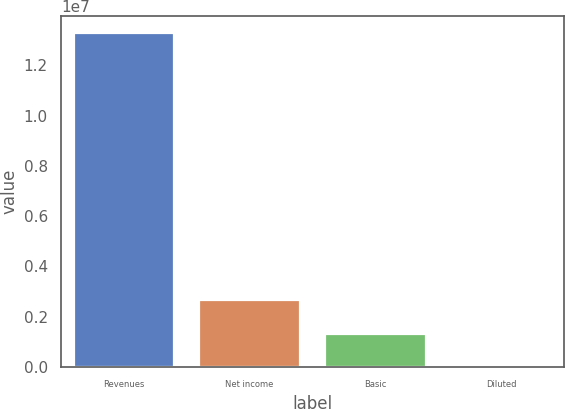Convert chart. <chart><loc_0><loc_0><loc_500><loc_500><bar_chart><fcel>Revenues<fcel>Net income<fcel>Basic<fcel>Diluted<nl><fcel>1.32903e+07<fcel>2.65807e+06<fcel>1.32903e+06<fcel>1.76<nl></chart> 